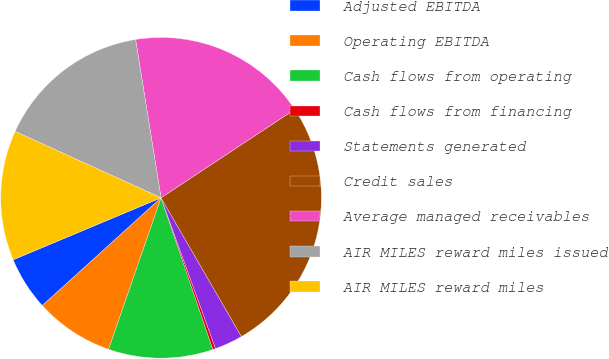Convert chart to OTSL. <chart><loc_0><loc_0><loc_500><loc_500><pie_chart><fcel>Adjusted EBITDA<fcel>Operating EBITDA<fcel>Cash flows from operating<fcel>Cash flows from financing<fcel>Statements generated<fcel>Credit sales<fcel>Average managed receivables<fcel>AIR MILES reward miles issued<fcel>AIR MILES reward miles<nl><fcel>5.41%<fcel>7.97%<fcel>10.54%<fcel>0.28%<fcel>2.84%<fcel>25.94%<fcel>18.24%<fcel>15.67%<fcel>13.11%<nl></chart> 